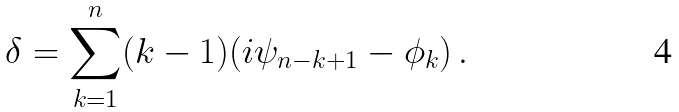<formula> <loc_0><loc_0><loc_500><loc_500>\delta = \sum _ { k = 1 } ^ { n } ( k - 1 ) ( i \psi _ { n - k + 1 } - \phi _ { k } ) \, .</formula> 